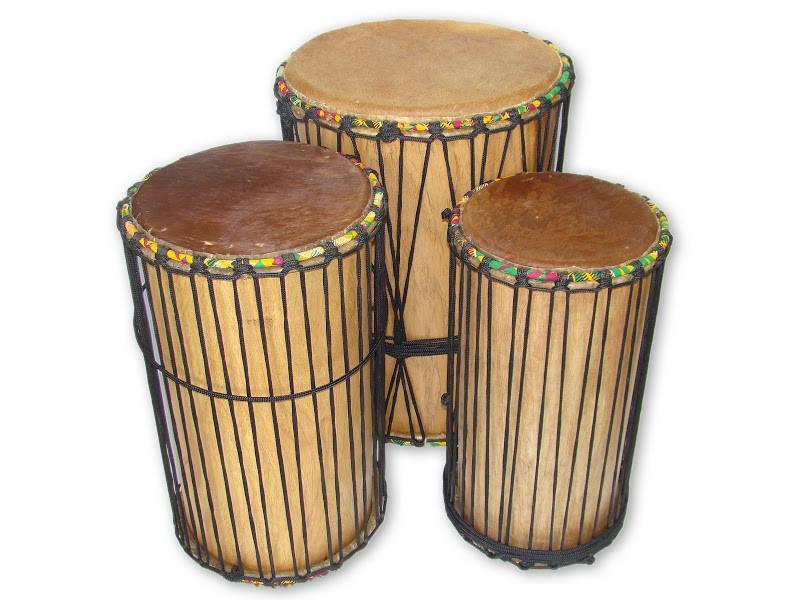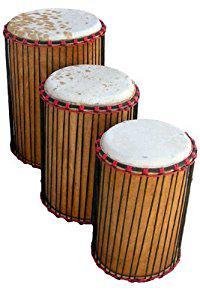The first image is the image on the left, the second image is the image on the right. For the images shown, is this caption "One image shows three close-together upright drums, with two standing in front and a bigger one behind them." true? Answer yes or no. Yes. The first image is the image on the left, the second image is the image on the right. Given the left and right images, does the statement "There are at least four drums." hold true? Answer yes or no. Yes. 